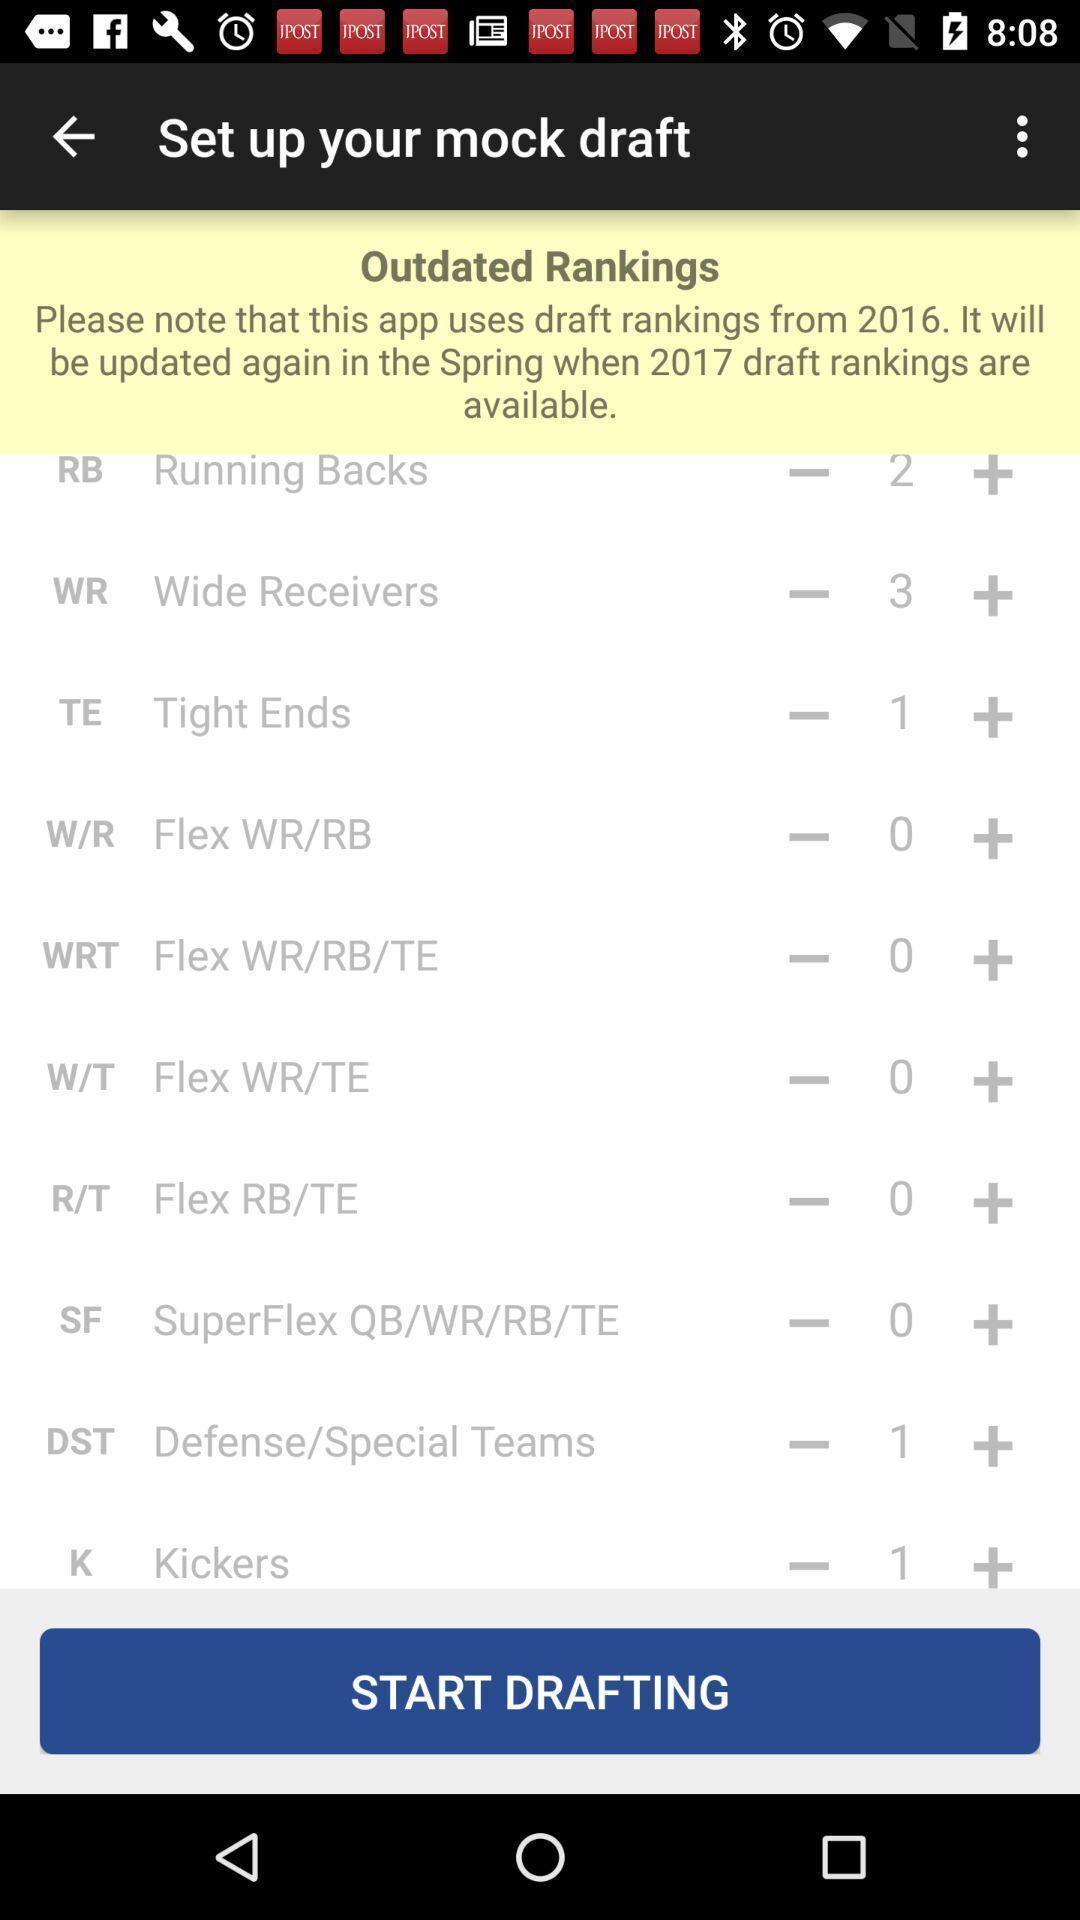Summarize the main components in this picture. Screen showing various teams with rankings. 